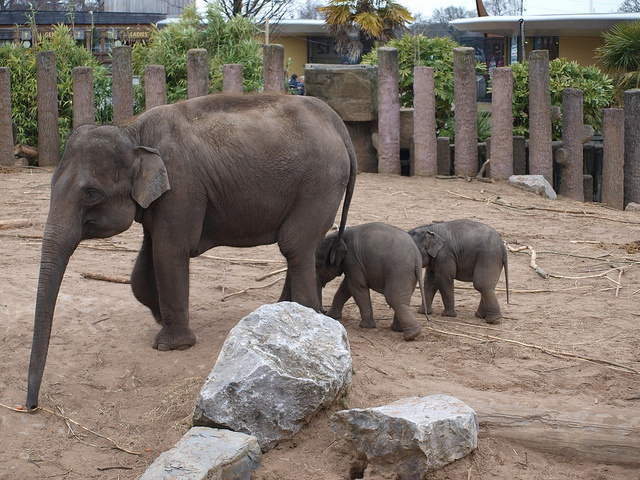Describe the objects in this image and their specific colors. I can see elephant in black and gray tones, elephant in black and gray tones, elephant in black and gray tones, people in black and purple tones, and people in black, gray, darkblue, and navy tones in this image. 